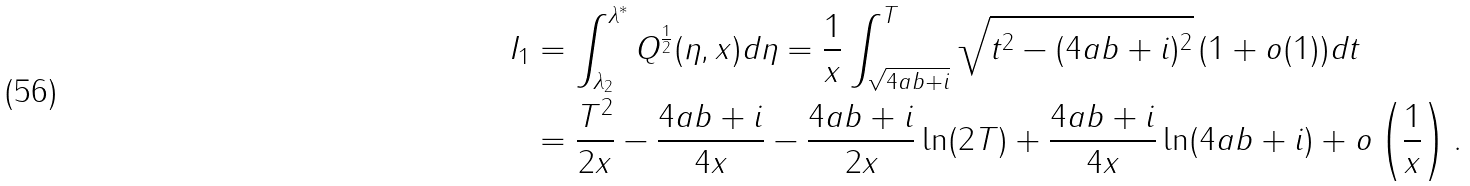<formula> <loc_0><loc_0><loc_500><loc_500>I _ { 1 } & = \int _ { \lambda _ { 2 } } ^ { \lambda ^ { * } } Q ^ { \frac { 1 } { 2 } } ( \eta , x ) d \eta = \frac { 1 } { x } \int _ { \sqrt { 4 a b + i } } ^ { T } \sqrt { t ^ { 2 } - ( 4 a b + i ) ^ { 2 } } \, ( 1 + o ( 1 ) ) d t \\ & = \frac { T ^ { 2 } } { 2 x } - \frac { 4 a b + i } { 4 x } - \frac { 4 a b + i } { 2 x } \ln ( 2 T ) + \frac { 4 a b + i } { 4 x } \ln ( 4 a b + i ) + o \left ( \frac { 1 } { x } \right ) .</formula> 